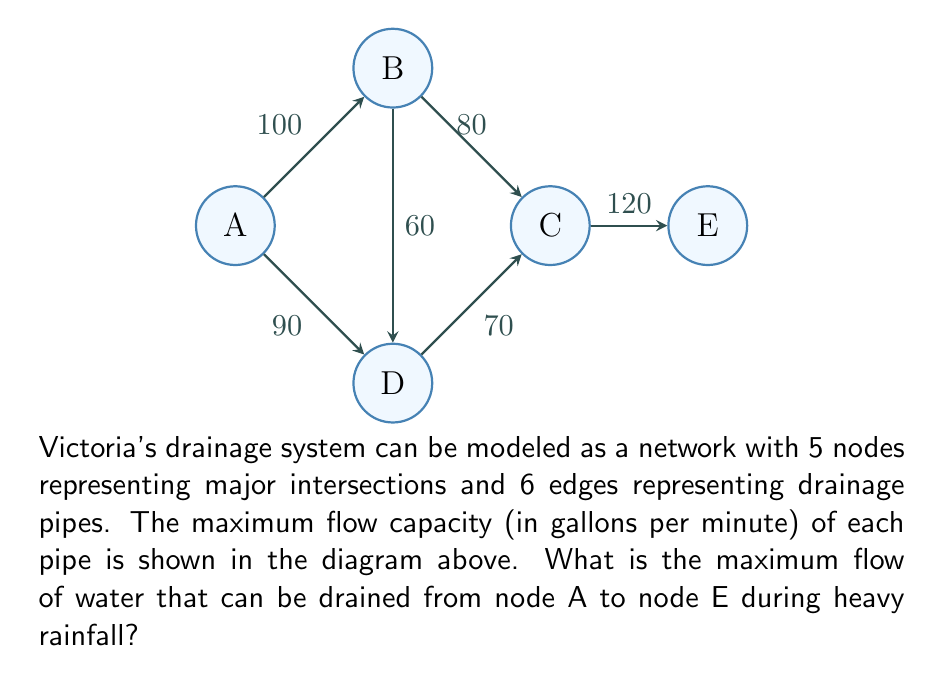Can you solve this math problem? To solve this problem, we need to use the concept of maximum flow in a network. We can apply the Ford-Fulkerson algorithm or the Edmonds-Karp algorithm to find the maximum flow from node A to node E. Let's use the Ford-Fulkerson method:

1) Initialize the flow on all edges to 0.

2) Find an augmenting path from A to E. We can use any path-finding algorithm, such as DFS or BFS. Let's find paths and their bottleneck capacities:

   Path 1: A-B-C-E (bottleneck = min(100, 80, 120) = 80)
   Flow after Path 1: 80

   Path 2: A-D-C-E (bottleneck = min(90, 70, 120-80) = 40)
   Flow after Path 2: 80 + 40 = 120

   Path 3: A-B-D-C-E (bottleneck = min(100-80, 60, 70-40, 120-120) = 20)
   Flow after Path 3: 120 + 20 = 140

3) No more augmenting paths exist, so the algorithm terminates.

The maximum flow is the sum of all the flows we've pushed through the network, which is 140 gallons per minute.

This solution ensures that the concerned parent in Victoria, Texas understands how the city's drainage system capacity is calculated during heavy rainfall, which is crucial for flood prevention and city planning.
Answer: 140 gallons per minute 